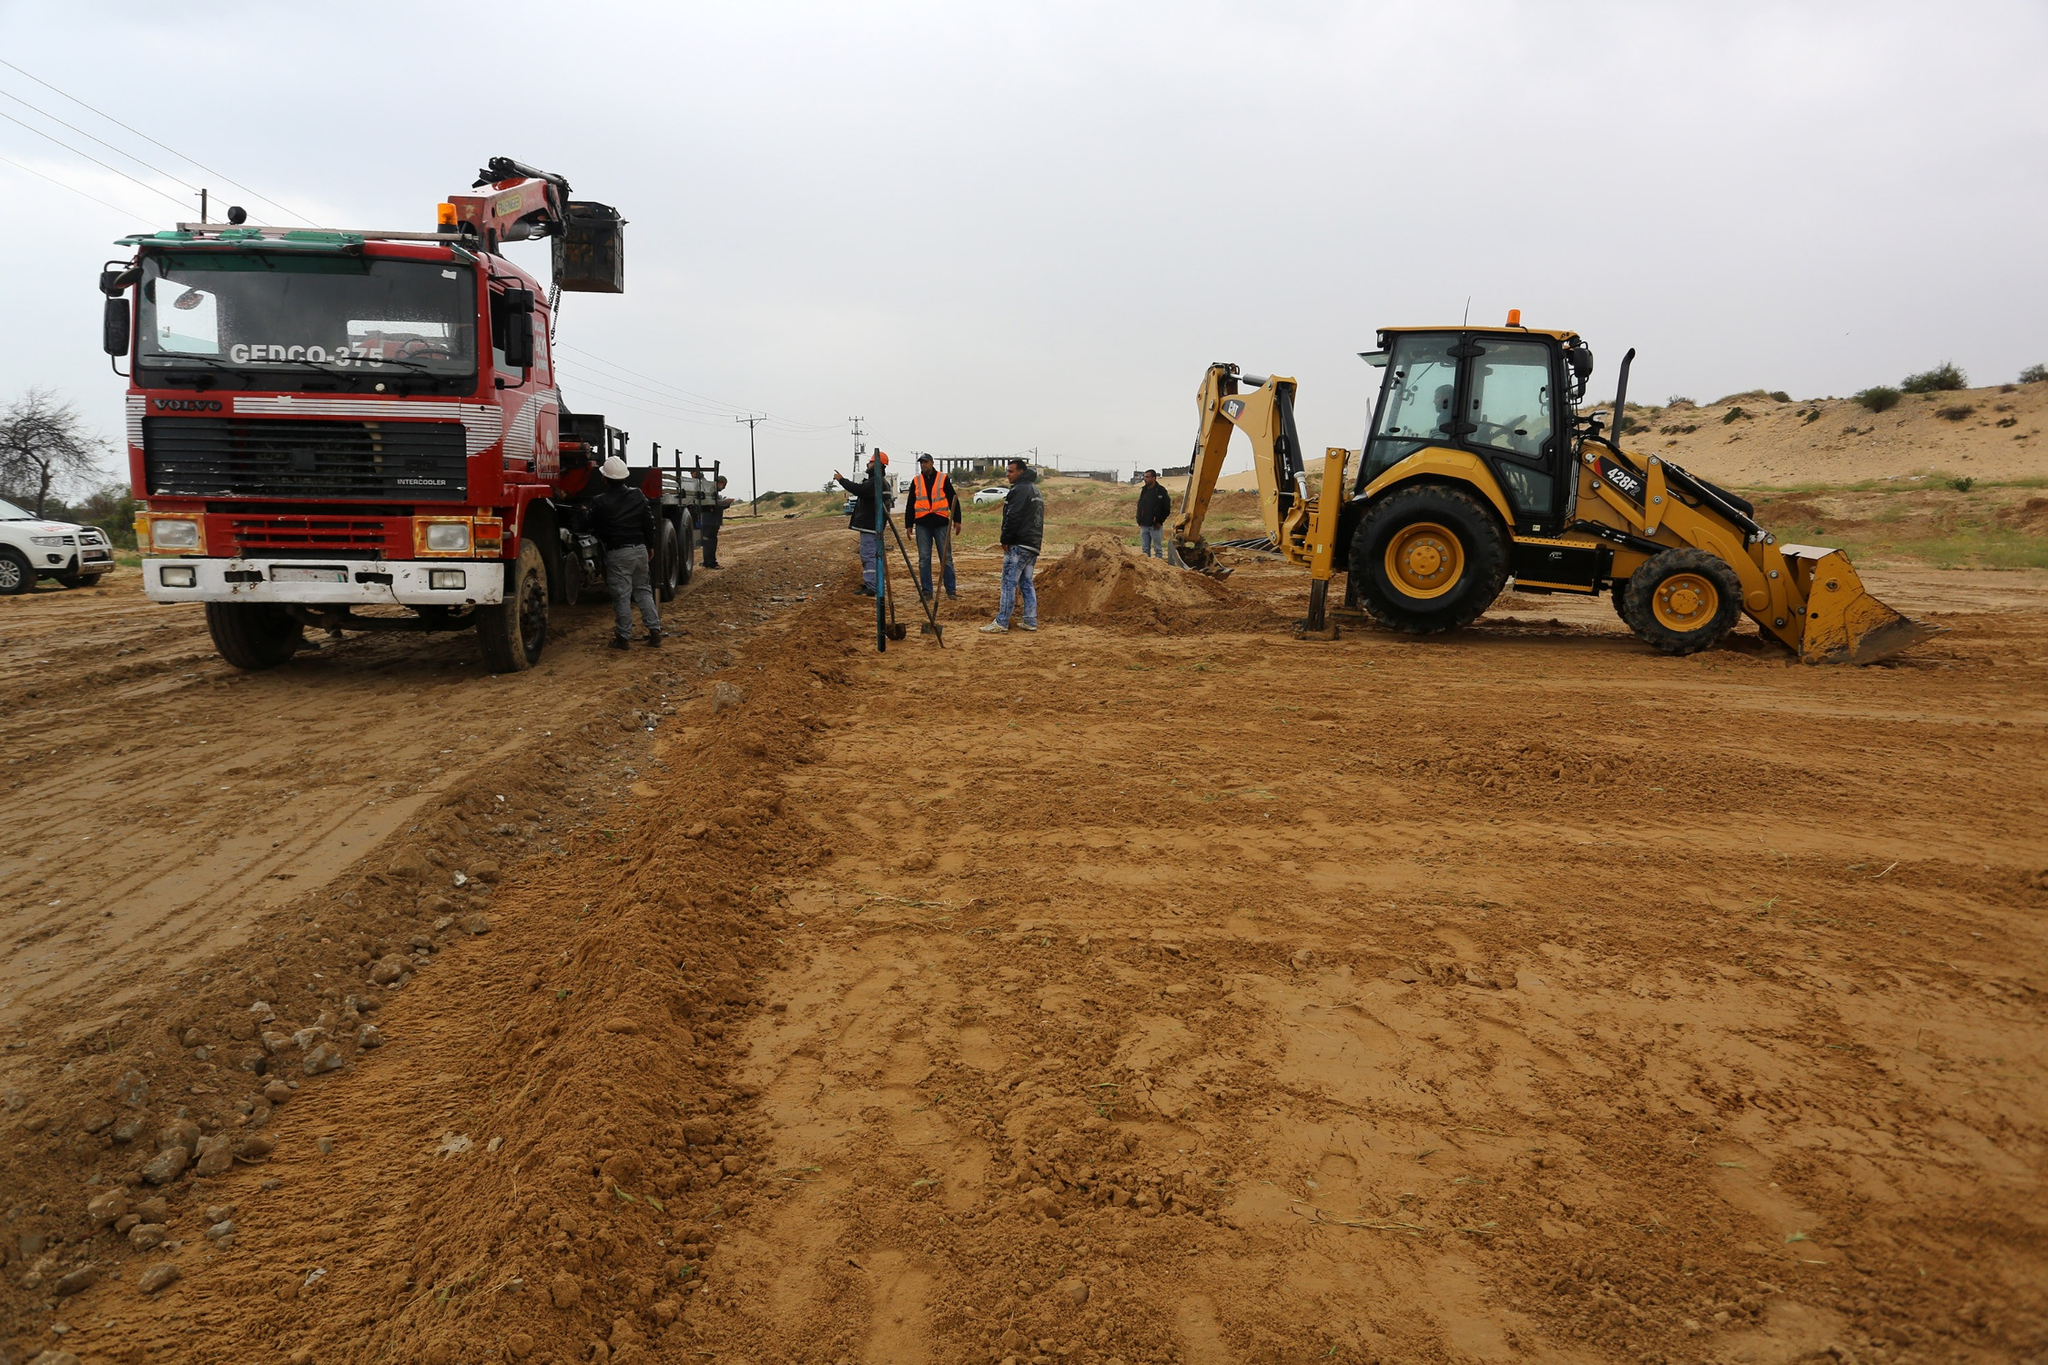What might the workers be discussing? The workers appear to be in the midst of a discussion about the day's plan. They could be reviewing blueprints or project guidelines, ensuring everyone is on the sharegpt4v/same page. Perhaps they’re talking about the best strategies for addressing a particular challenge they’ve encountered, or simply coordinating the sequence of tasks to optimize efficiency and safety. 